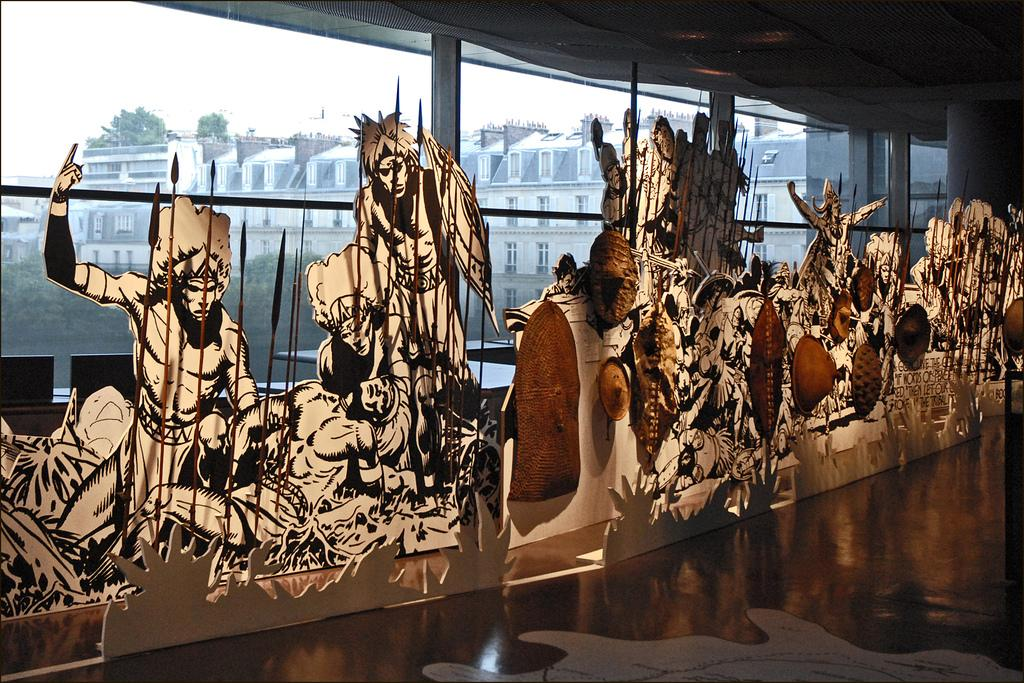What type of characters can be seen in the image? There are cartoon characters in the image. Where are the cartoon characters located? The cartoon characters are placed on the floor. What architectural feature can be seen in the image? There are glass windows visible in the image. What type of crow is perched on the cartoon character's shoulder in the image? There is no crow present in the image; it features cartoon characters placed on the floor and glass windows. 